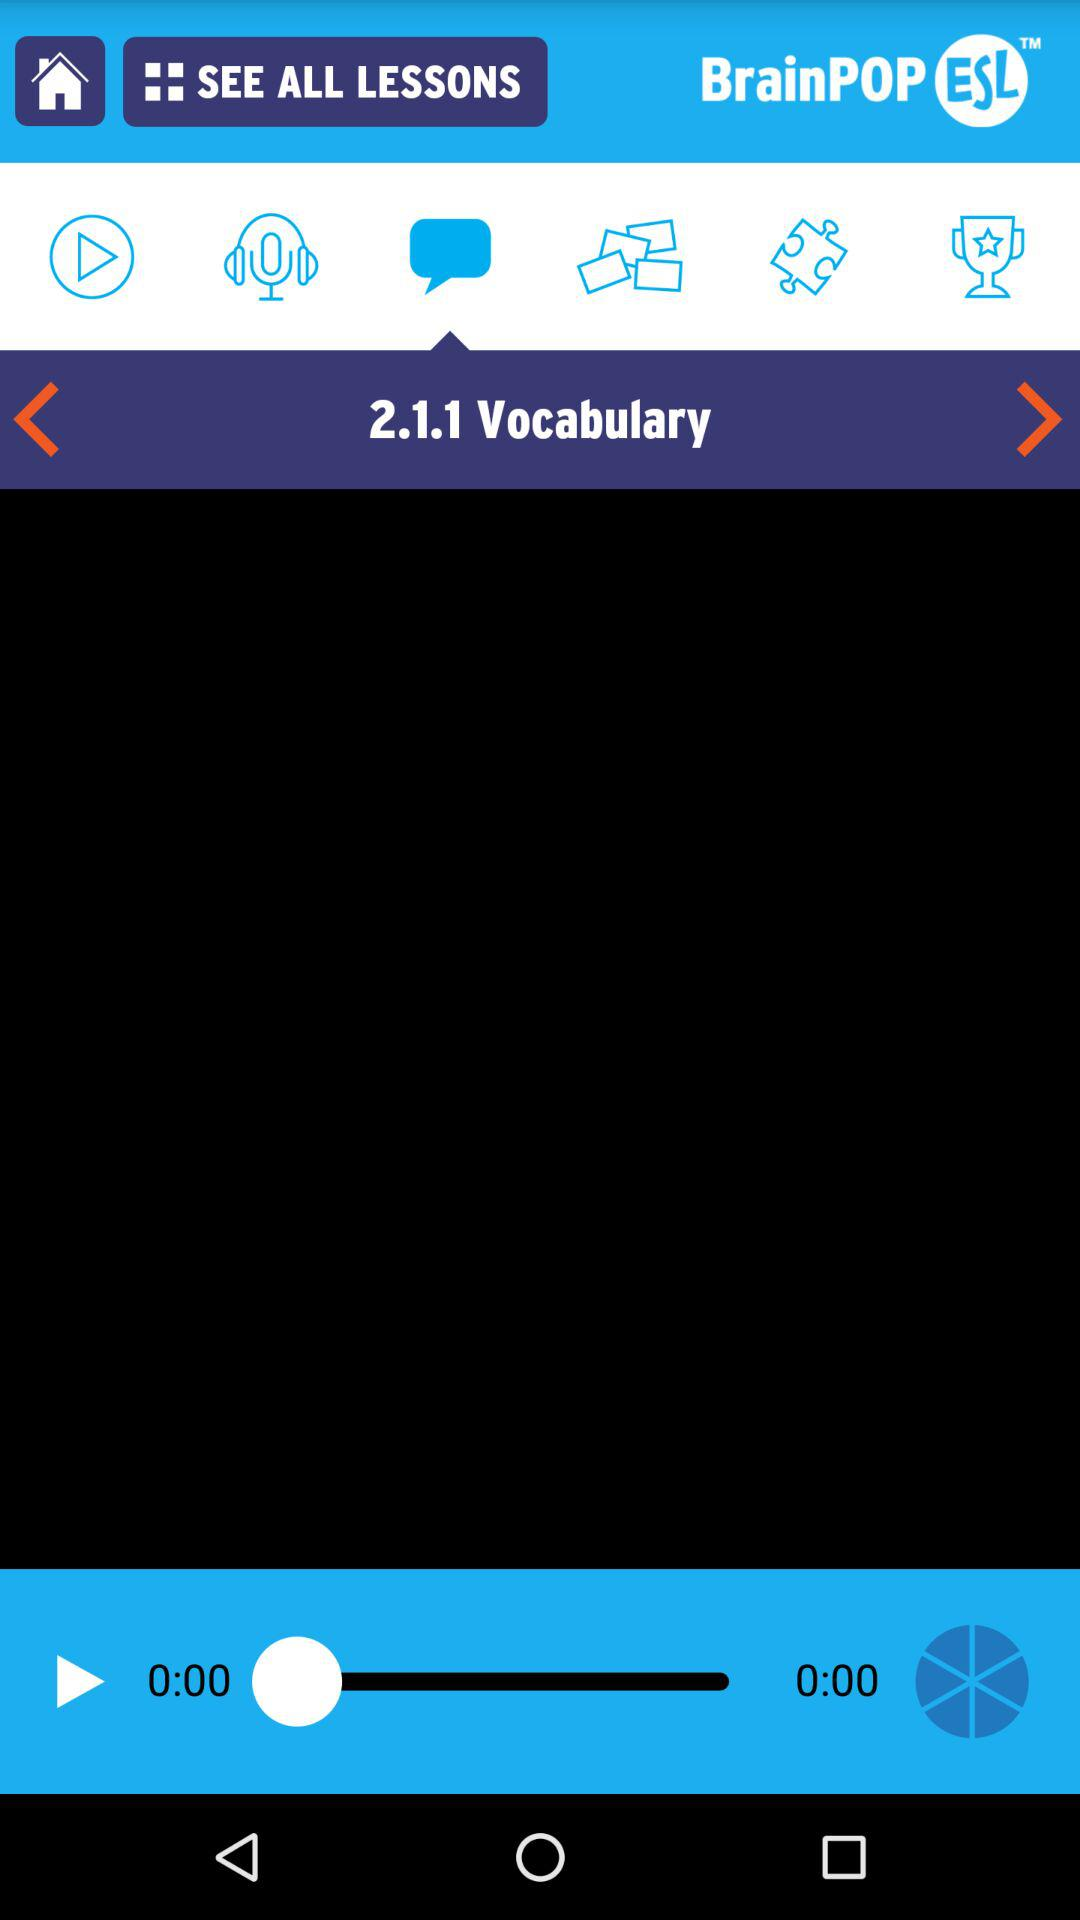How many seconds into the video is the user?
Answer the question using a single word or phrase. 0 